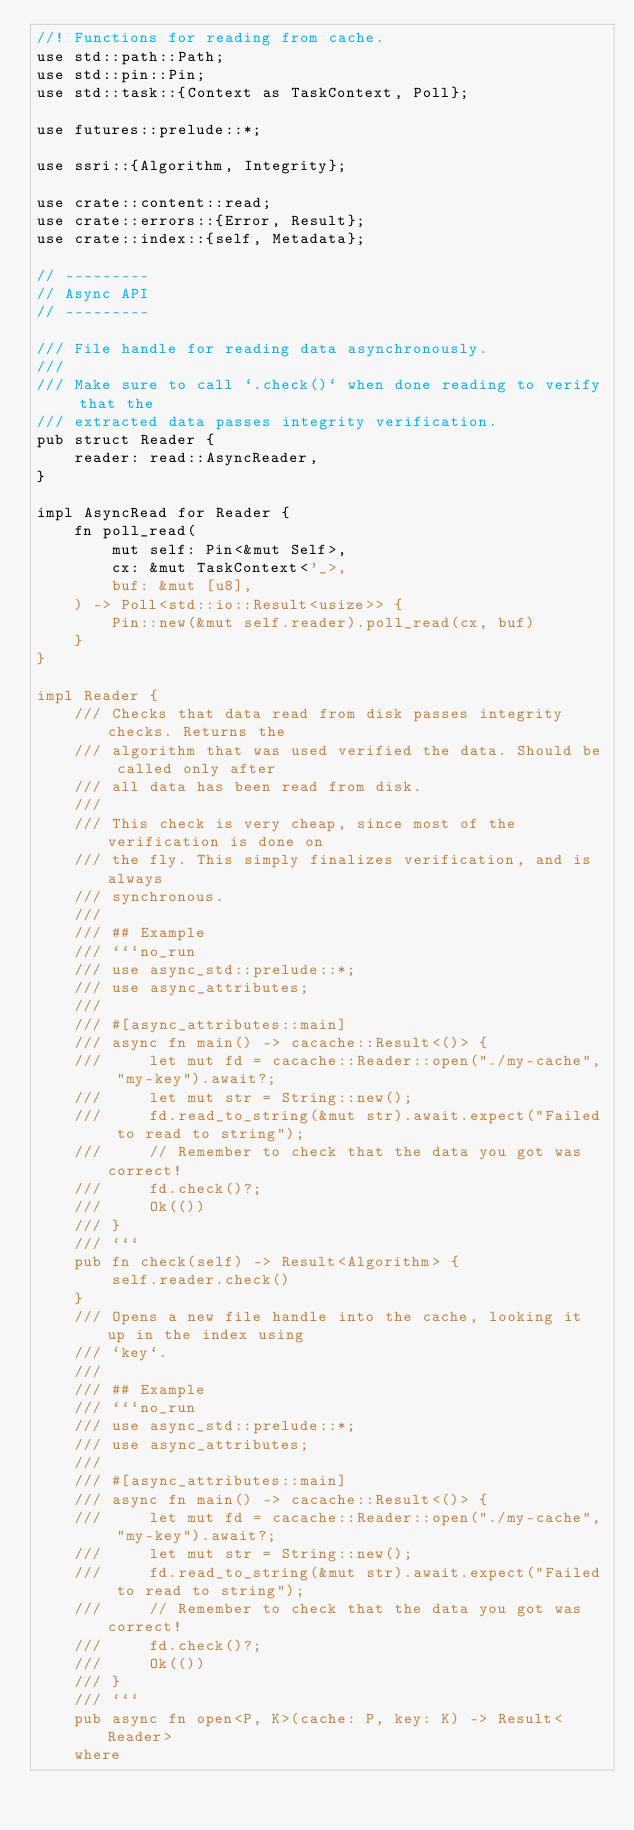Convert code to text. <code><loc_0><loc_0><loc_500><loc_500><_Rust_>//! Functions for reading from cache.
use std::path::Path;
use std::pin::Pin;
use std::task::{Context as TaskContext, Poll};

use futures::prelude::*;

use ssri::{Algorithm, Integrity};

use crate::content::read;
use crate::errors::{Error, Result};
use crate::index::{self, Metadata};

// ---------
// Async API
// ---------

/// File handle for reading data asynchronously.
///
/// Make sure to call `.check()` when done reading to verify that the
/// extracted data passes integrity verification.
pub struct Reader {
    reader: read::AsyncReader,
}

impl AsyncRead for Reader {
    fn poll_read(
        mut self: Pin<&mut Self>,
        cx: &mut TaskContext<'_>,
        buf: &mut [u8],
    ) -> Poll<std::io::Result<usize>> {
        Pin::new(&mut self.reader).poll_read(cx, buf)
    }
}

impl Reader {
    /// Checks that data read from disk passes integrity checks. Returns the
    /// algorithm that was used verified the data. Should be called only after
    /// all data has been read from disk.
    ///
    /// This check is very cheap, since most of the verification is done on
    /// the fly. This simply finalizes verification, and is always
    /// synchronous.
    ///
    /// ## Example
    /// ```no_run
    /// use async_std::prelude::*;
    /// use async_attributes;
    ///
    /// #[async_attributes::main]
    /// async fn main() -> cacache::Result<()> {
    ///     let mut fd = cacache::Reader::open("./my-cache", "my-key").await?;
    ///     let mut str = String::new();
    ///     fd.read_to_string(&mut str).await.expect("Failed to read to string");
    ///     // Remember to check that the data you got was correct!
    ///     fd.check()?;
    ///     Ok(())
    /// }
    /// ```
    pub fn check(self) -> Result<Algorithm> {
        self.reader.check()
    }
    /// Opens a new file handle into the cache, looking it up in the index using
    /// `key`.
    ///
    /// ## Example
    /// ```no_run
    /// use async_std::prelude::*;
    /// use async_attributes;
    ///
    /// #[async_attributes::main]
    /// async fn main() -> cacache::Result<()> {
    ///     let mut fd = cacache::Reader::open("./my-cache", "my-key").await?;
    ///     let mut str = String::new();
    ///     fd.read_to_string(&mut str).await.expect("Failed to read to string");
    ///     // Remember to check that the data you got was correct!
    ///     fd.check()?;
    ///     Ok(())
    /// }
    /// ```
    pub async fn open<P, K>(cache: P, key: K) -> Result<Reader>
    where</code> 